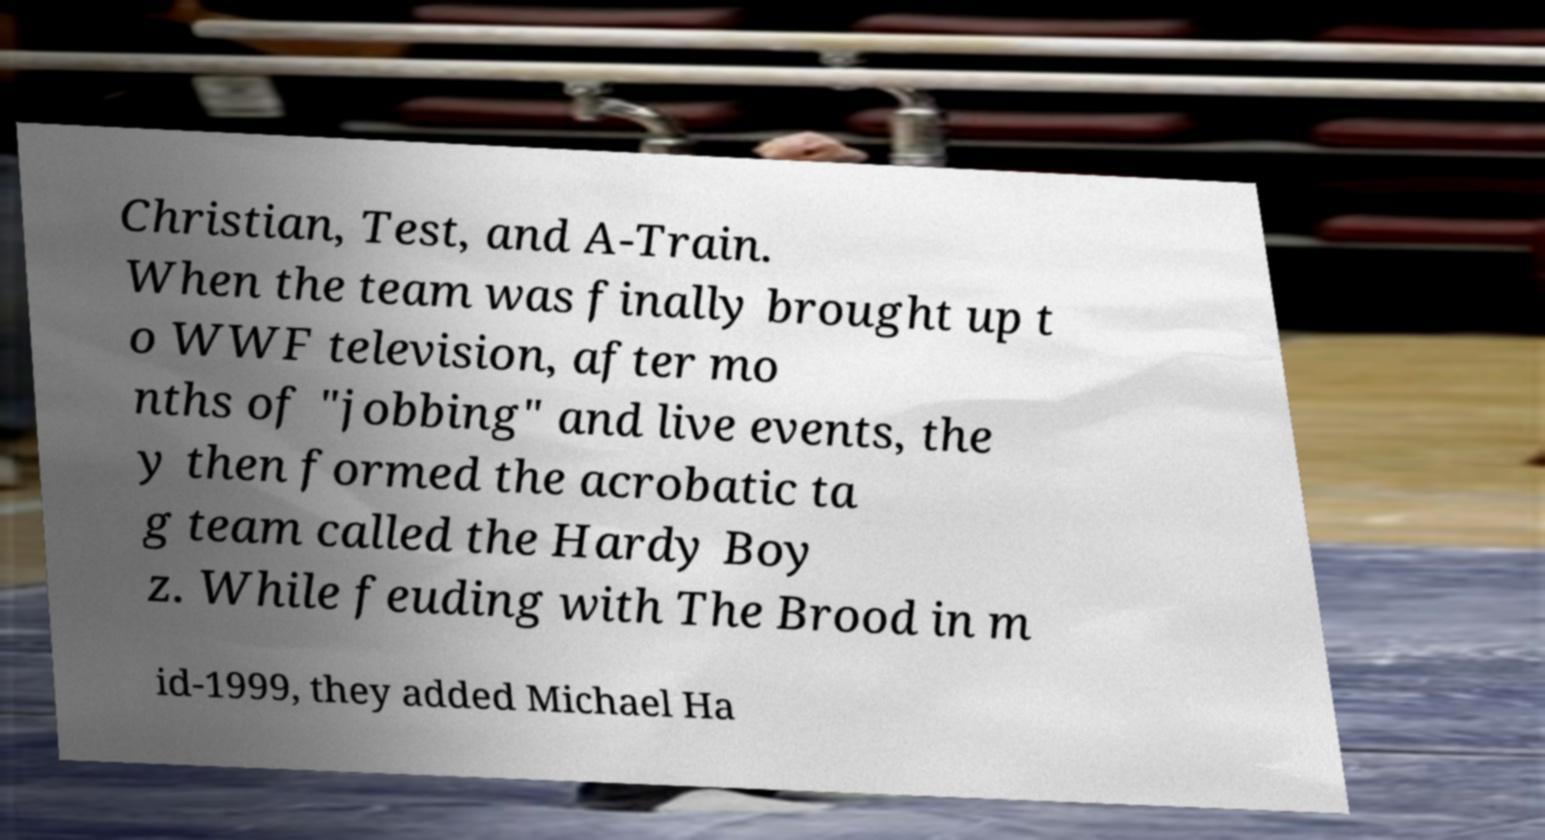There's text embedded in this image that I need extracted. Can you transcribe it verbatim? Christian, Test, and A-Train. When the team was finally brought up t o WWF television, after mo nths of "jobbing" and live events, the y then formed the acrobatic ta g team called the Hardy Boy z. While feuding with The Brood in m id-1999, they added Michael Ha 